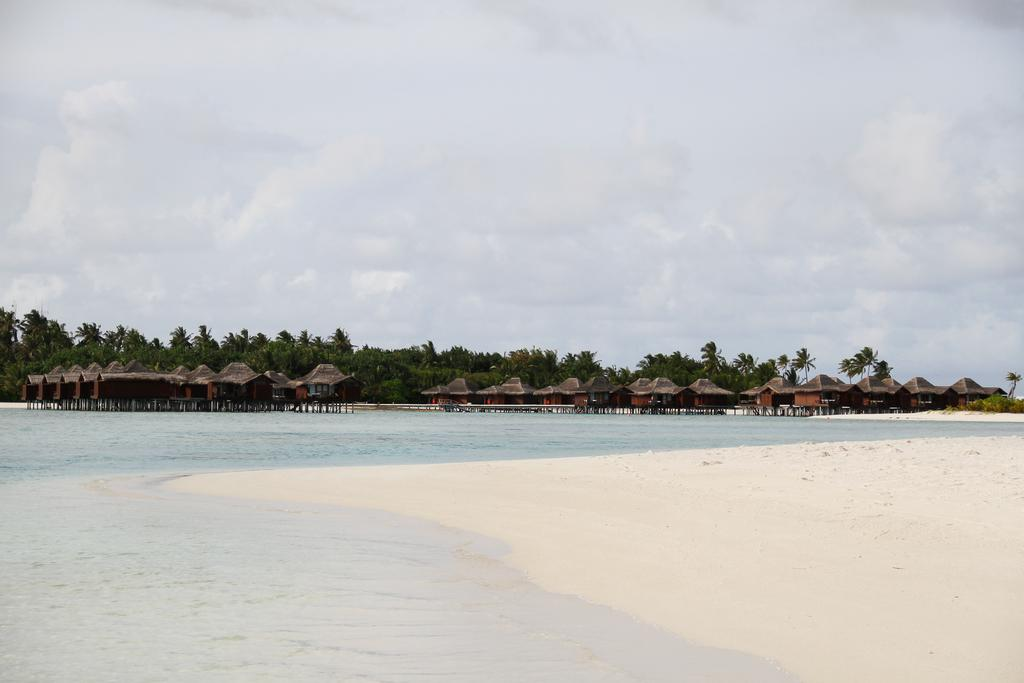What type of terrain is visible at the bottom of the image? There is sand and a beach at the bottom of the image. What structures can be seen in the background of the image? There are houses and trees in the background of the image. What is visible at the top of the image? The sky is visible at the top of the image. Where is the club located in the image? There is no club present in the image. Can you see a lift being used by a visitor in the image? There is no lift or visitor present in the image. 